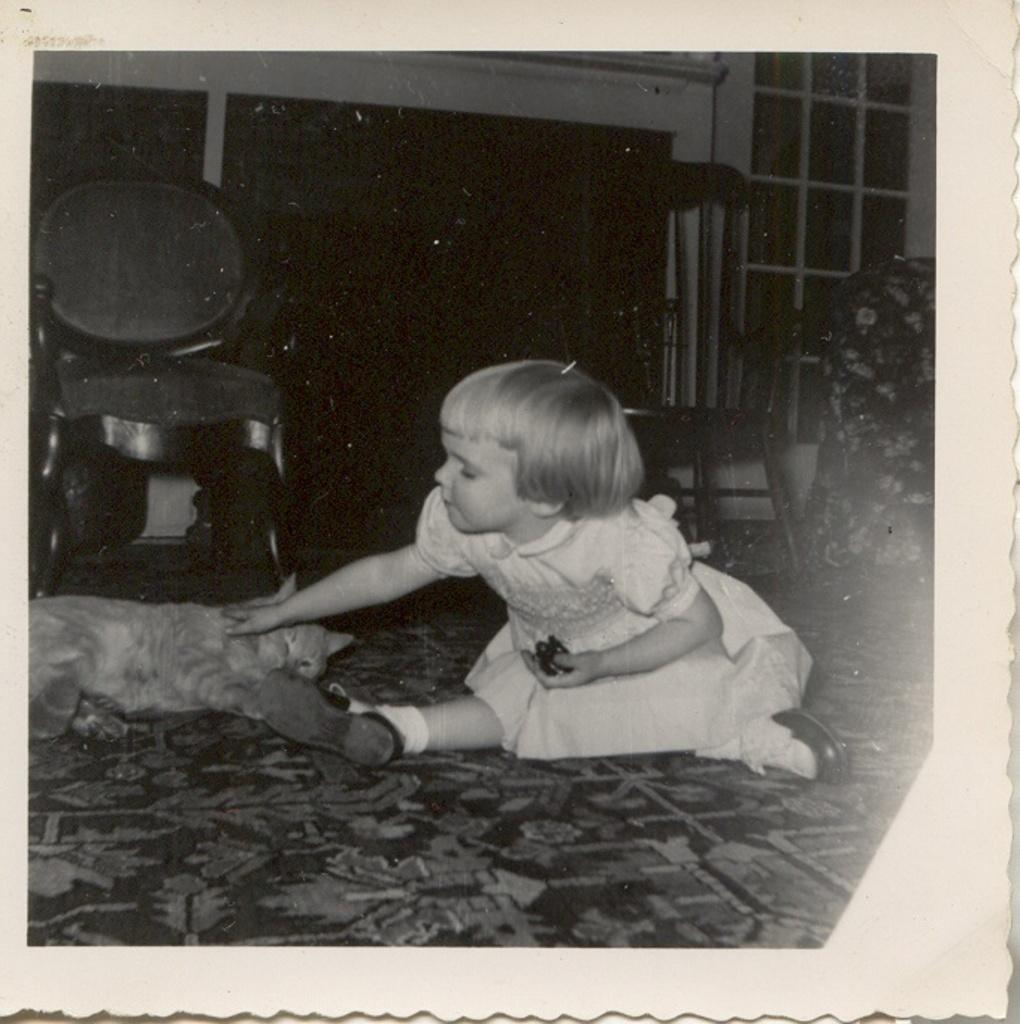What is the girl in the image doing? The girl is sitting in the image. What is the girl holding in her hand? The girl is holding an object in her hand. What animal is present in the image? There is a cat in the image. What type of furniture can be seen in the background of the image? There are chairs in the background of the image. What architectural feature is visible in the background of the image? There is a window in the background of the image. What type of bone is the girl feeding to her grandmother in the image? There is no grandmother or bone present in the image. What type of fork is the cat using to eat its food in the image? There is no fork or food for the cat present in the image. 